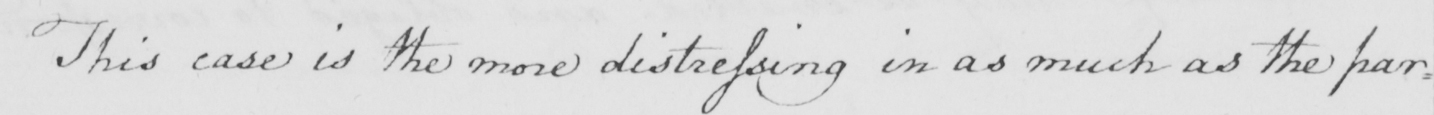What does this handwritten line say? This case is the more distressing in as much as the par= 